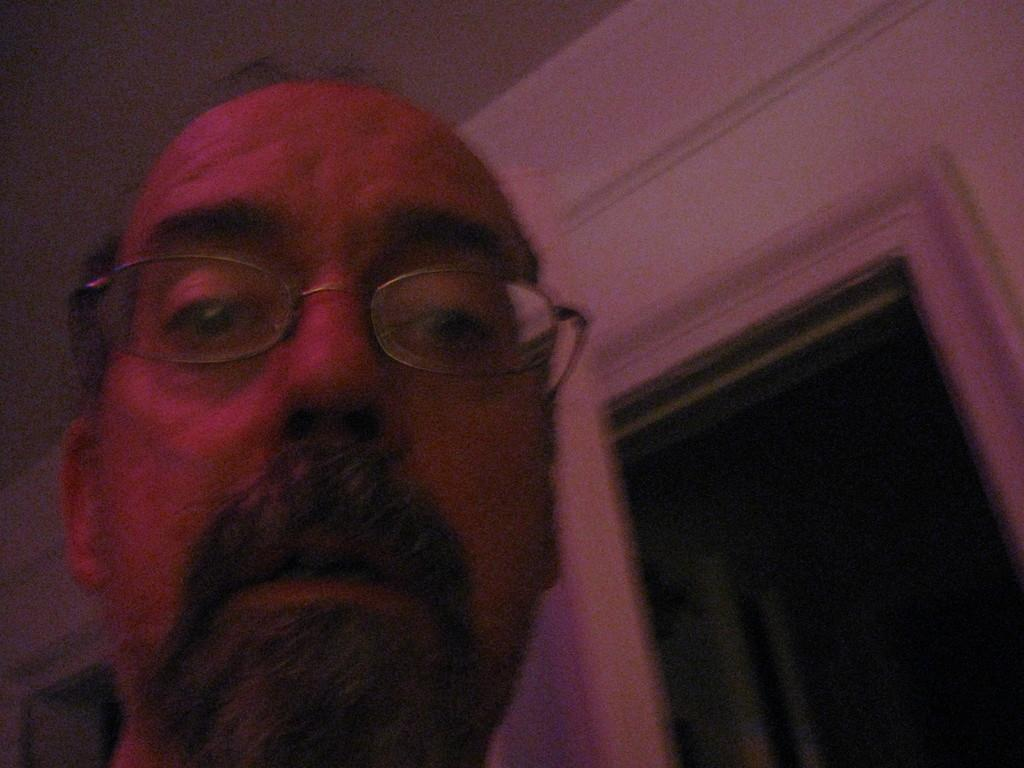What is the main subject of the image? There is a person's head in the image. What type of structure is visible in the image? There is a wall and a roof in the image. What type of jelly can be seen on the person's head in the image? There is no jelly present on the person's head in the image. What type of cake is being used to hold the basket in the image? There is no cake or basket present in the image. 